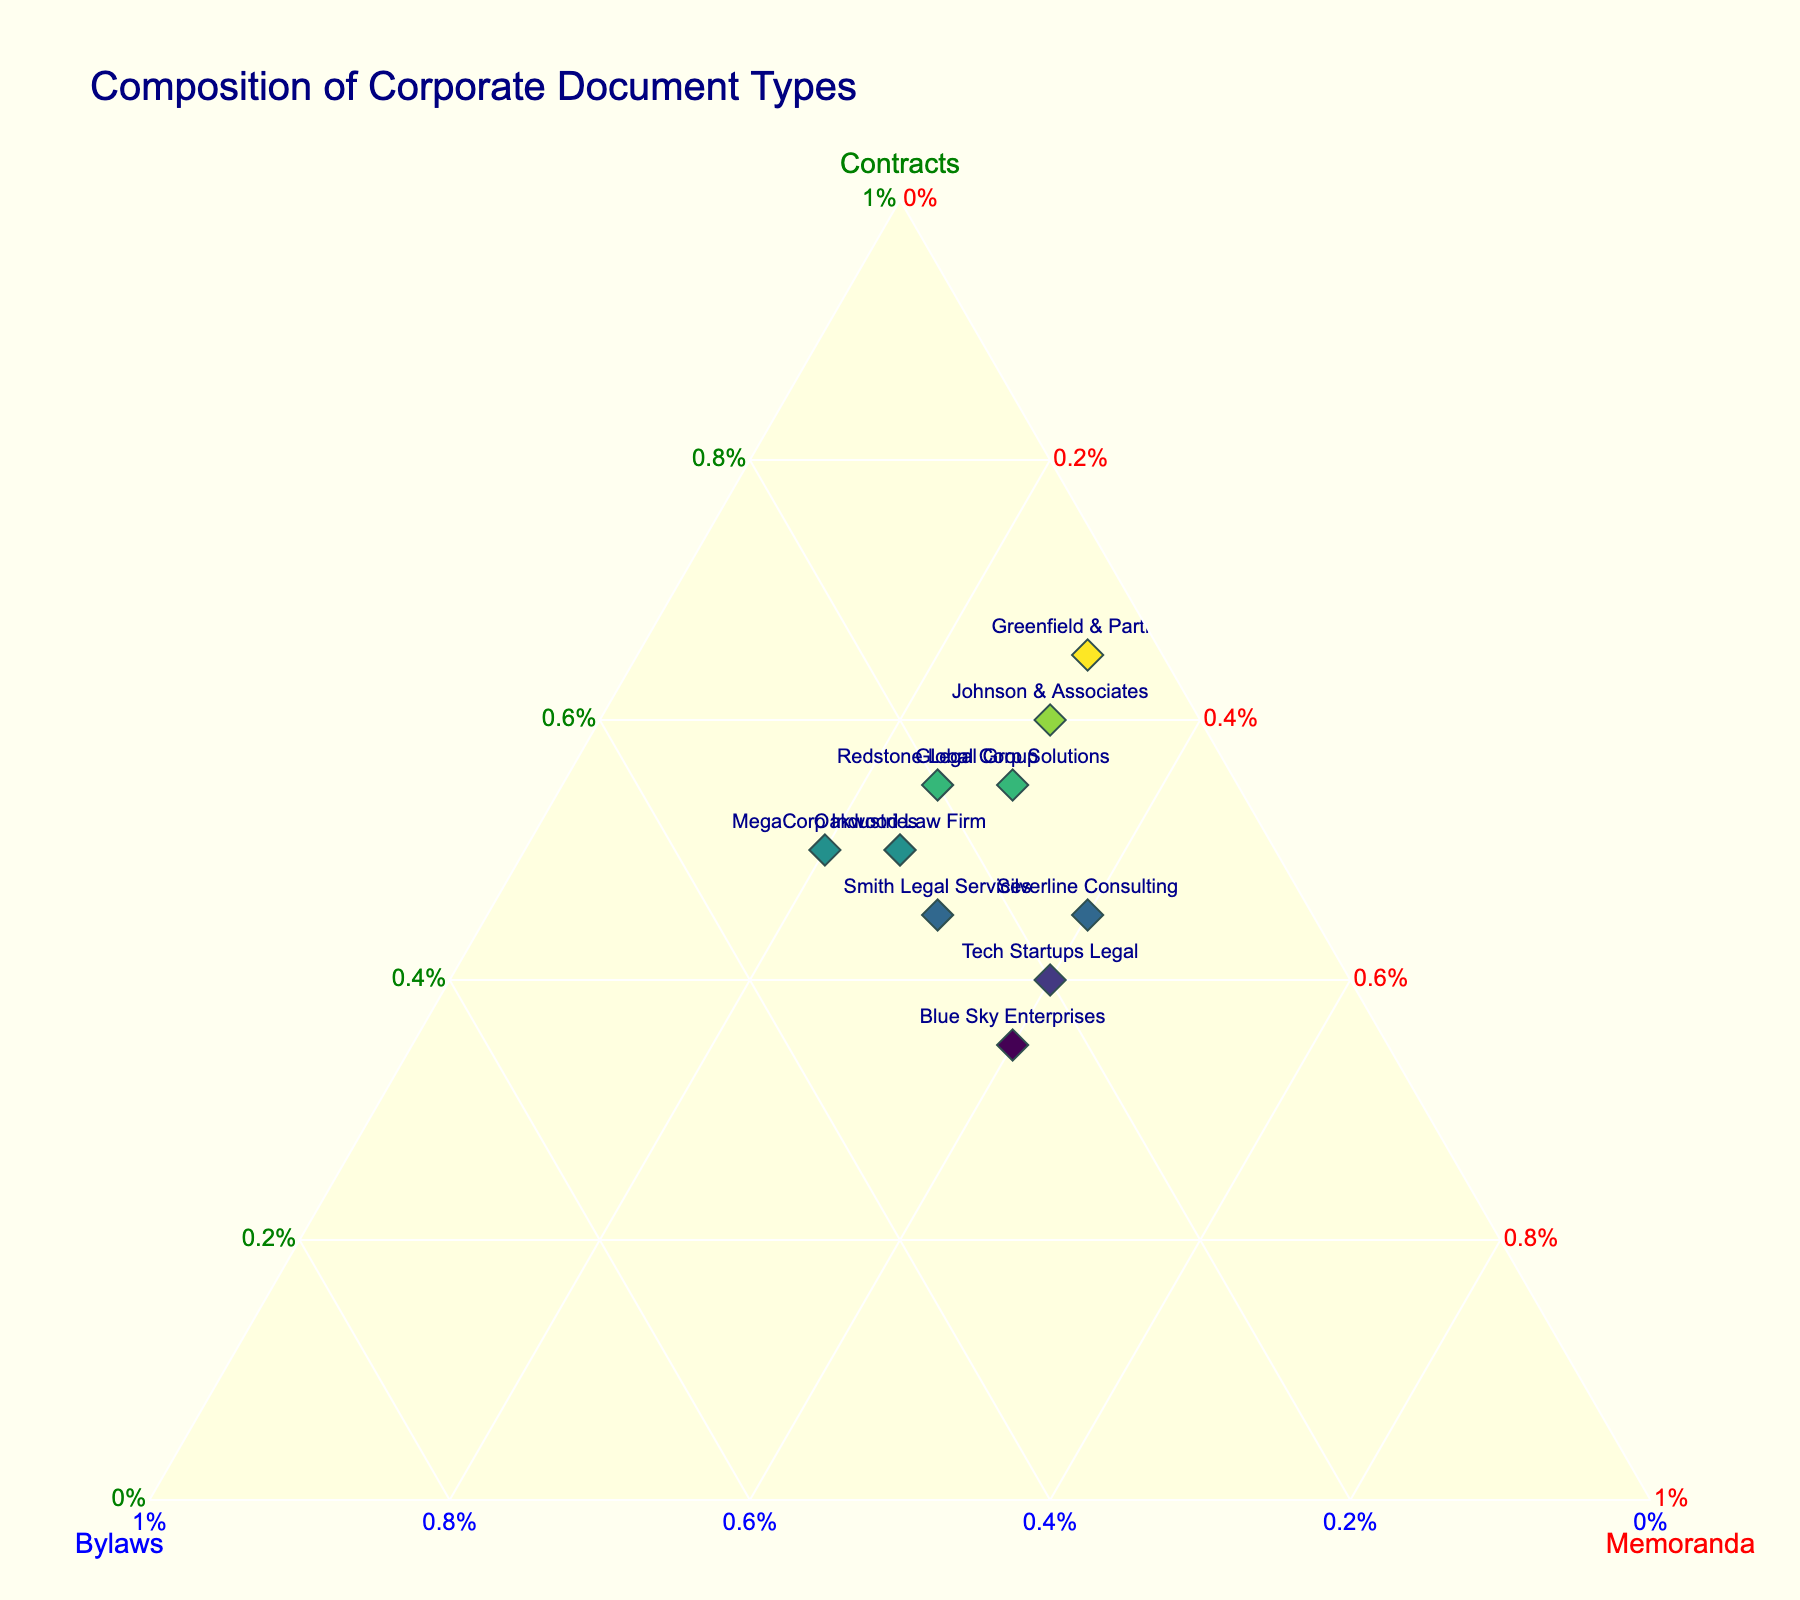What's the title of the figure? The title is prominently located at the top of the figure, where the title text states 'Composition of Corporate Document Types'.
Answer: Composition of Corporate Document Types What is the color assigned to the 'Memoranda' axis? Each axis is labeled with a title and a corresponding color. The axis labeled 'Memoranda' is colored red.
Answer: Red Which firm specializes most in Contracts based on the plot? By examining the points placed furthest along the 'Contracts' axis, Johnson & Associates, with the highest value of 60 for Contracts, specializes most in this type of document.
Answer: Johnson & Associates Which firm has an equal composition of 25% for both Bylaws and Memoranda? Reviewing the plot, look for the point closest to where the Bylaws and Memoratnda axes meet, having values of 25 for both. Oakwood Law Firm fits this criterion.
Answer: Oakwood Law Firm Among the firms that produce 30% Memoranda, which has the highest proportion of Bylaws? Filter out the firms with 30% Memoranda, then identify the one with the highest Bylaws percentage. MegaCorp Industries, producing 30% Bylaws, fits this description.
Answer: MegaCorp Industries What is the average percentage of Contracts for firms preparing 25% Bylaws? Identify firms with 25% Bylaws (Smith Legal Services, Oakwood Law Firm, Blue Sky Enterprises), sum their Contracts percentages: 45 + 50 + 35, then divide by 3 (sum = 130, average = 130/3 ≈ 43.33).
Answer: 43.33 Compare the Contracts composition between Greenfield & Partners and Tech Startups Legal. Which one has a higher percentage? Locate both firms on the plot; Greenfield & Partners has 65% Contracts while Tech Startups Legal has 40%. Hence, Greenfield & Partners has a higher percentage.
Answer: Greenfield & Partners Which firm has the smallest Bylaws value? By comparing all Bylaws percentages, the minimum value is 5% held by Greenfield & Partners.
Answer: Greenfield & Partners List the firms that have a composition of at least 40% Memoranda. Evaluate firms that have Memoranda values greater than or equal to 40%. Tech Startups Legal, Blue Sky Enterprises, and Silverline Consulting meet this criterion.
Answer: Tech Startups Legal, Blue Sky Enterprises, Silverline Consulting 